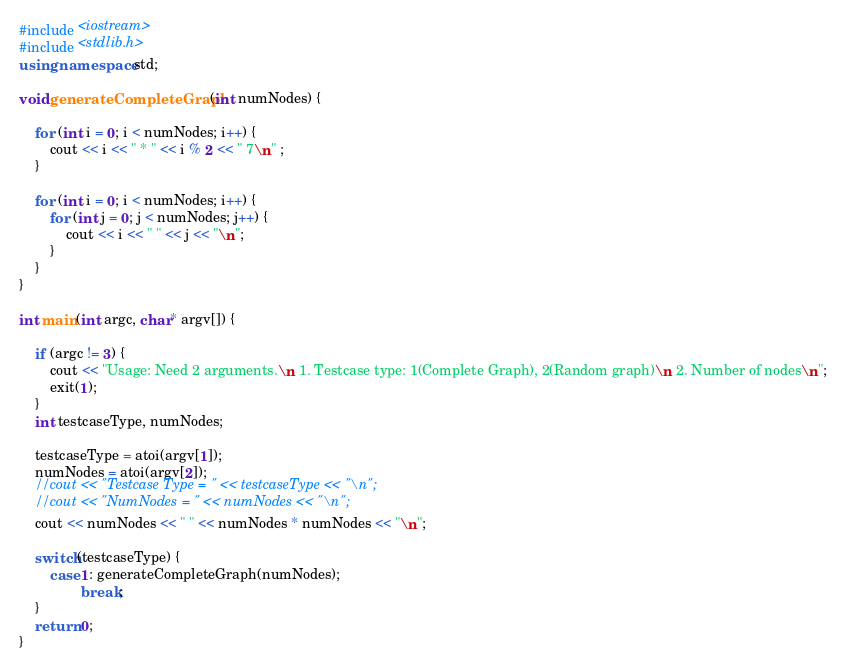<code> <loc_0><loc_0><loc_500><loc_500><_C++_>#include <iostream>
#include <stdlib.h>
using namespace std;

void generateCompleteGraph(int numNodes) {

    for (int i = 0; i < numNodes; i++) {
        cout << i << " * " << i % 2 << " 7\n" ;
    }

    for (int i = 0; i < numNodes; i++) {
        for (int j = 0; j < numNodes; j++) {
            cout << i << " " << j << "\n";
        }
    }
}

int main(int argc, char* argv[]) {

    if (argc != 3) {
        cout << "Usage: Need 2 arguments.\n 1. Testcase type: 1(Complete Graph), 2(Random graph)\n 2. Number of nodes\n";
        exit(1);
    }
    int testcaseType, numNodes;
    
    testcaseType = atoi(argv[1]);
    numNodes = atoi(argv[2]);
    //cout << "Testcase Type = " << testcaseType << "\n";
    //cout << "NumNodes = " << numNodes << "\n";
    cout << numNodes << " " << numNodes * numNodes << "\n";

    switch(testcaseType) {
        case 1: generateCompleteGraph(numNodes);
                break;
    }
    return 0;
}
</code> 